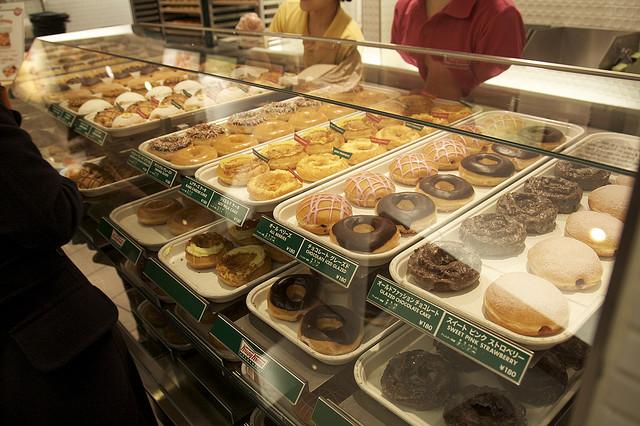How many employees are visible?
Keep it brief. 2. Where are the chocolate covered donuts?
Give a very brief answer. On right. Are there jelly filled donuts in this picture?
Quick response, please. Yes. In what country might these baked goods be for sale?
Give a very brief answer. China. Is there any meat?
Keep it brief. No. 